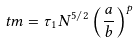Convert formula to latex. <formula><loc_0><loc_0><loc_500><loc_500>\ t m = \tau _ { 1 } N ^ { 5 / 2 } \left ( \frac { a } { b } \right ) ^ { p }</formula> 